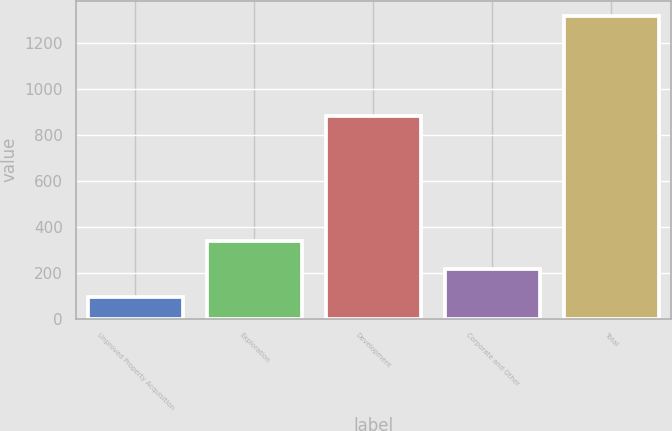Convert chart to OTSL. <chart><loc_0><loc_0><loc_500><loc_500><bar_chart><fcel>Unproved Property Acquisition<fcel>Exploration<fcel>Development<fcel>Corporate and Other<fcel>Total<nl><fcel>92<fcel>337<fcel>881<fcel>214.5<fcel>1317<nl></chart> 